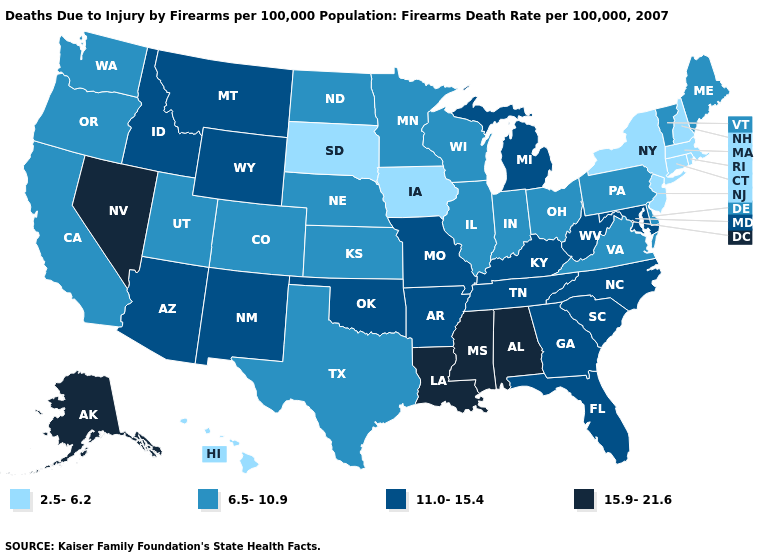What is the value of Montana?
Give a very brief answer. 11.0-15.4. Name the states that have a value in the range 11.0-15.4?
Keep it brief. Arizona, Arkansas, Florida, Georgia, Idaho, Kentucky, Maryland, Michigan, Missouri, Montana, New Mexico, North Carolina, Oklahoma, South Carolina, Tennessee, West Virginia, Wyoming. Name the states that have a value in the range 6.5-10.9?
Keep it brief. California, Colorado, Delaware, Illinois, Indiana, Kansas, Maine, Minnesota, Nebraska, North Dakota, Ohio, Oregon, Pennsylvania, Texas, Utah, Vermont, Virginia, Washington, Wisconsin. Does Vermont have the lowest value in the Northeast?
Be succinct. No. Name the states that have a value in the range 6.5-10.9?
Answer briefly. California, Colorado, Delaware, Illinois, Indiana, Kansas, Maine, Minnesota, Nebraska, North Dakota, Ohio, Oregon, Pennsylvania, Texas, Utah, Vermont, Virginia, Washington, Wisconsin. Among the states that border Texas , does Oklahoma have the highest value?
Write a very short answer. No. What is the value of Maine?
Answer briefly. 6.5-10.9. What is the value of Nebraska?
Be succinct. 6.5-10.9. What is the highest value in the USA?
Quick response, please. 15.9-21.6. Does Iowa have a higher value than Michigan?
Write a very short answer. No. Name the states that have a value in the range 6.5-10.9?
Answer briefly. California, Colorado, Delaware, Illinois, Indiana, Kansas, Maine, Minnesota, Nebraska, North Dakota, Ohio, Oregon, Pennsylvania, Texas, Utah, Vermont, Virginia, Washington, Wisconsin. Name the states that have a value in the range 15.9-21.6?
Write a very short answer. Alabama, Alaska, Louisiana, Mississippi, Nevada. Name the states that have a value in the range 15.9-21.6?
Concise answer only. Alabama, Alaska, Louisiana, Mississippi, Nevada. What is the value of South Dakota?
Give a very brief answer. 2.5-6.2. Does Maine have the same value as Louisiana?
Answer briefly. No. 